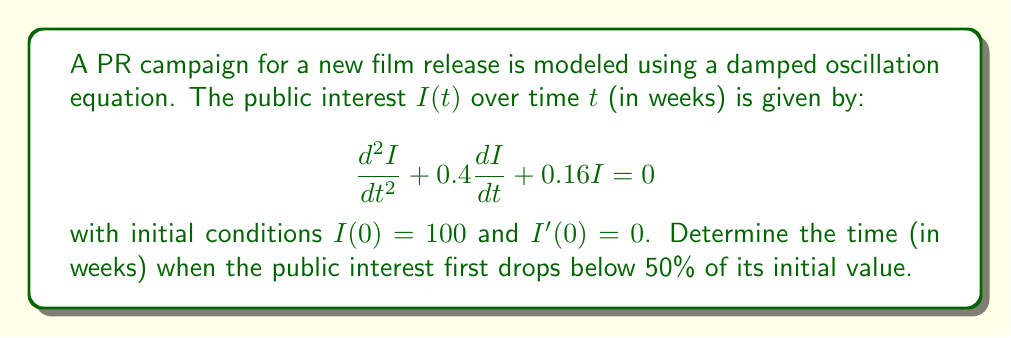Solve this math problem. To solve this problem, we need to follow these steps:

1) The general solution for this second-order linear differential equation is:

   $$I(t) = e^{-0.2t}(A\cos(0.4t) + B\sin(0.4t))$$

2) Using the initial conditions:
   $I(0) = 100$ gives us $A = 100$
   $I'(0) = 0$ gives us $B = 50$

3) Therefore, our specific solution is:

   $$I(t) = e^{-0.2t}(100\cos(0.4t) + 50\sin(0.4t))$$

4) We need to find when $I(t) = 50$ (50% of the initial value):

   $$50 = e^{-0.2t}(100\cos(0.4t) + 50\sin(0.4t))$$

5) This equation can't be solved algebraically. We need to use numerical methods or graphing to find the solution.

6) Using a graphing calculator or computer software, we can plot this function and find the first time it crosses the line $y = 50$.

7) The solution is approximately $t \approx 3.65$ weeks.

This solution represents the time when public interest first drops to 50% of its initial value, which is a key metric in assessing the effectiveness of the PR campaign.
Answer: The public interest first drops below 50% of its initial value after approximately 3.65 weeks. 